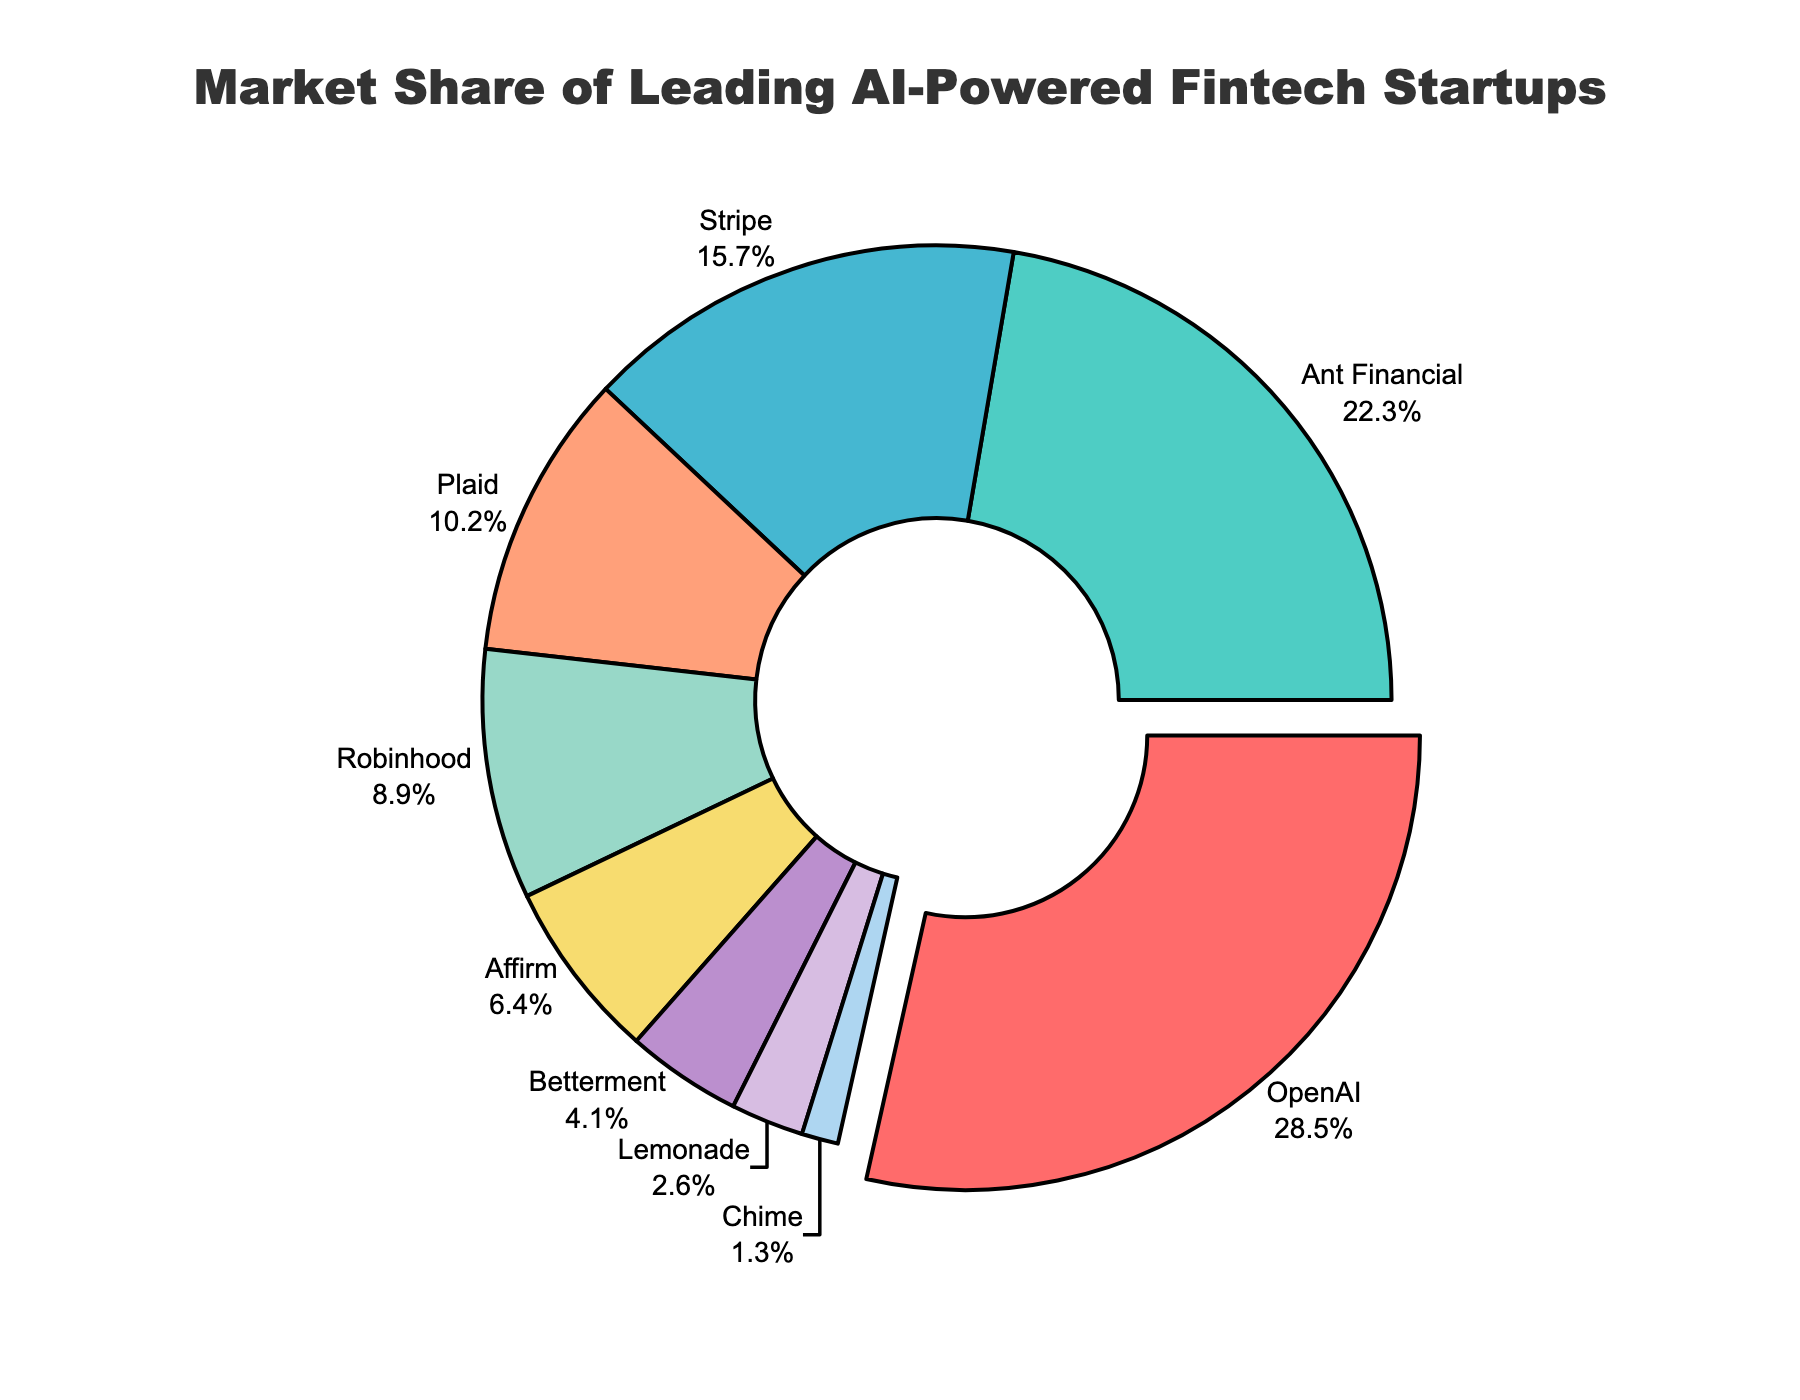What percentage of the market does OpenAI hold? The figure shows the percentage of the market share for each company. OpenAI has a slice with "28.5%" labeled visibly outside of it.
Answer: 28.5% Which company has the second-largest market share, and what is it? By looking for the largest slices after OpenAI, we identify Ant Financial as the one with the next largest slice labeled "22.3%".
Answer: Ant Financial, 22.3% Which two companies combined have a market share closest to 30%? Analyzing pairs of companies, we find that Plaid (10.2%) and Robinhood (8.9%) together sum to 19.1%, while Affirm (6.4%) and Betterment (4.1%) sum to 10.5%.  The closest pair is Stripe (15.7%) and Plaid (10.2%) which add up to 25.9%.
Answer: Stripe and Plaid By how much does the market share of OpenAI exceed that of Robinhood? First, find the market shares of OpenAI (28.5%) and Robinhood (8.9%). Then compute the difference: 28.5% - 8.9% = 19.6%.
Answer: 19.6% What is the combined market share of companies with a share of less than 10% each? Identify companies with less than 10%: Plaid (10.2% slightly above), Robinhood (8.9%), Affirm (6.4%), Betterment (4.1%), Lemonade (2.6%), Chime (1.3%). Sum: 8.9% + 6.4% + 4.1% + 2.6% + 1.3% = 23.3%.
Answer: 23.3% What color is used to represent Stripe's market share? The pie chart assigns a unique color to each company. Stripe is the third largest slice, shown in green.
Answer: Green Which company has the smallest market share, and what is it? The smallest slice belongs to Chime with a market share of 1.3%, as indicated by the smallest labeled segment.
Answer: Chime, 1.3% How does the sum of the market shares of Affirm and Betterment compare to the market share of Stripe? Calculate the sum of Affirm (6.4%) and Betterment (4.1%): 6.4% + 4.1% = 10.5%. Compare with Stripe's market share (15.7%): 10.5% < 15.7%.
Answer: Less than Stripe If Ant Financial and OpenAI are combined into one, what would their new market share and relative position be? The combined market share is OpenAI (28.5%) + Ant Financial (22.3%) = 50.8%. This new entity would have over half of the market share and be the dominant company in the pie chart.
Answer: 50.8%, Dominant Which label is positioned closest to the top of the pie chart? Observe the positioning of the labels around the pie chart. The slice starting from the top-right is rotated with OpenAI pulled slightly out and close to the top.
Answer: OpenAI 